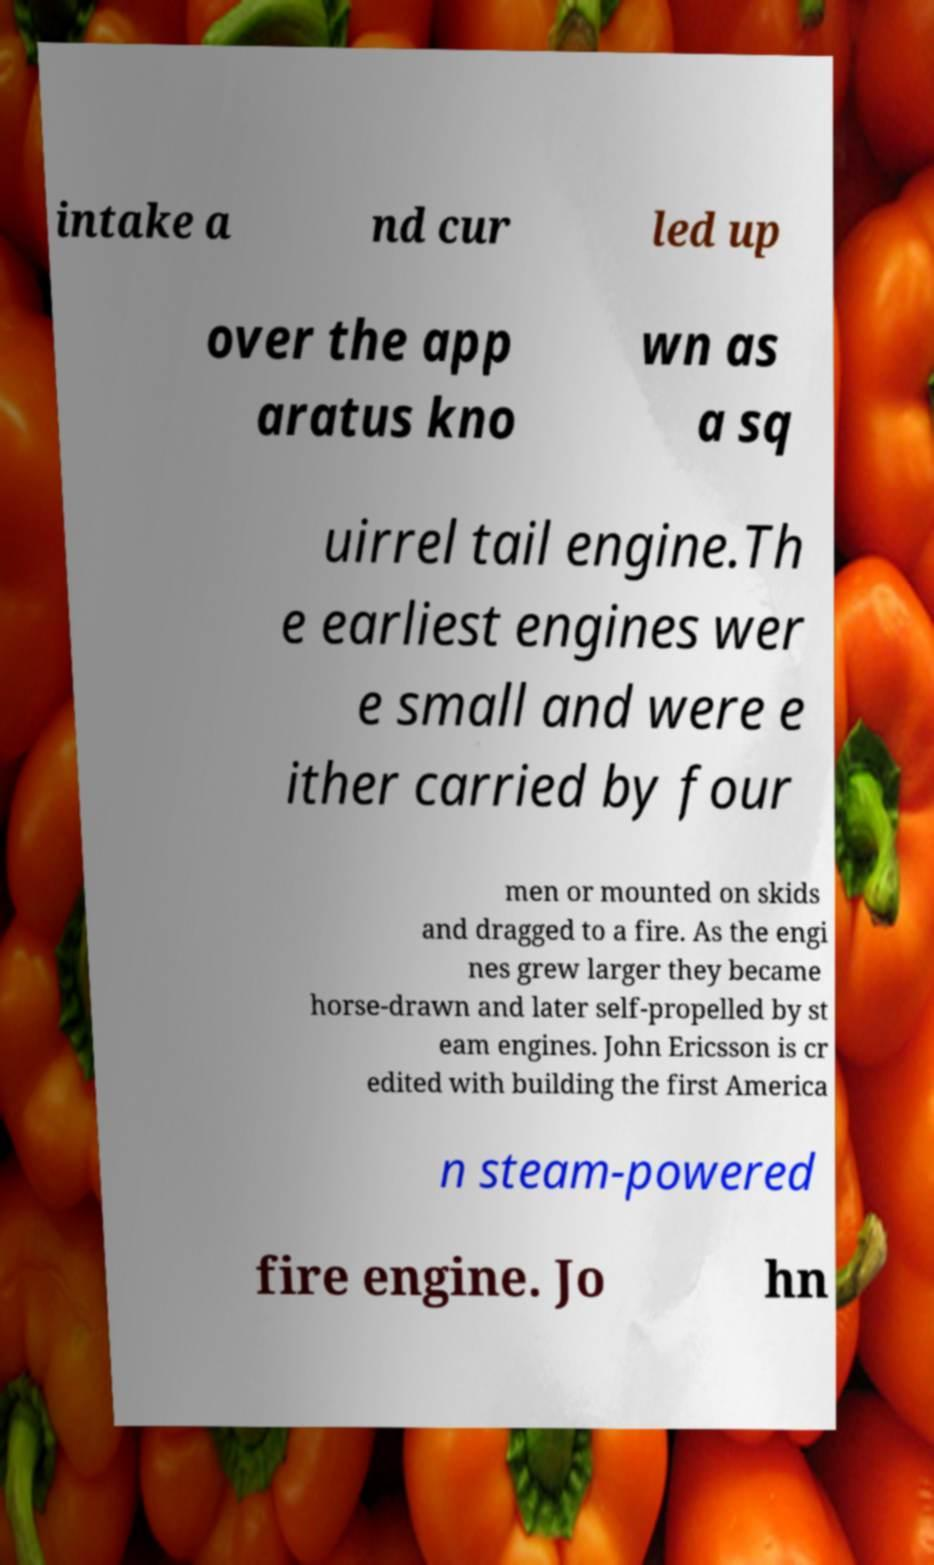Can you accurately transcribe the text from the provided image for me? intake a nd cur led up over the app aratus kno wn as a sq uirrel tail engine.Th e earliest engines wer e small and were e ither carried by four men or mounted on skids and dragged to a fire. As the engi nes grew larger they became horse-drawn and later self-propelled by st eam engines. John Ericsson is cr edited with building the first America n steam-powered fire engine. Jo hn 